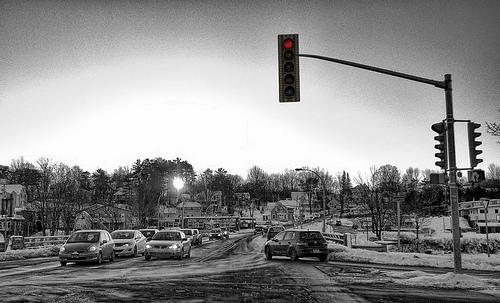Give the sentiment expressed in the image, considering the content of the scene. The image conveys a serene yet active winter day in a suburban setting, with vehicles moving along the road and a clear presence of snow, suggesting a cold weather scenario. Count the number of cars, including other vehicles, present in the image. There are six vehicles in the image - four cars, one van, and one SUV. List the types of vehicles on the street in the image. There are cars, a van, and an SUV on the street in the image. Analyze the object interaction in the image by describing how the trees and the buildings relate to each other. The trees are sparse and leafless, likely due to the winter season, and they are interspersed among the buildings, creating a blend of natural and urban elements along the roadside. Identify the type of weather hinted at in the image, considering the environmental elements. The weather appears to be cold and possibly snowy, as evidenced by the snow on the ground and the bare trees, suggesting a winter scene. Perform a complex reasoning task by answering which side of the street the cars are driving on, given the available information. The cars are driving on the right side of the street, as indicated by their positioning in the lanes and the direction they face relative to the traffic light. Describe the scene depicted in the image, including any significant features or actions. The image portrays a busy suburban street scene during winter. There are multiple vehicles on the road, including cars, a van, and an SUV. A traffic light shows a red signal, and there is visible snow on the ground and bare trees, indicating cold weather. Buildings line the street, contributing to the urban environment. Mention the color of the traffic light visible in the image and where it is located. The traffic light is red and is positioned at the top left corner of the image. Identify the primary elements and their positions in the image. The primary elements in the image include a red traffic light at the top left corner, a street filled with vehicles in the lower part of the image, buildings lining the street, and a snowy landscape with bare trees, indicating a winter setting. 